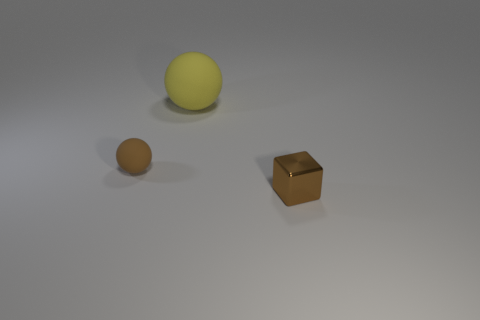There is a brown object in front of the brown thing behind the brown block; how big is it?
Provide a short and direct response. Small. What number of other objects are there of the same size as the yellow object?
Give a very brief answer. 0. Is there a large cyan rubber object of the same shape as the metal thing?
Offer a very short reply. No. What number of other objects are the same shape as the tiny brown metallic thing?
Ensure brevity in your answer.  0. There is a big rubber thing; does it have the same shape as the tiny brown thing to the left of the big matte thing?
Offer a terse response. Yes. Is there any other thing that is made of the same material as the yellow sphere?
Keep it short and to the point. Yes. What material is the large object that is the same shape as the small rubber object?
Provide a succinct answer. Rubber. How many tiny objects are yellow rubber spheres or blue metal cylinders?
Make the answer very short. 0. Are there fewer big yellow matte things on the left side of the brown metallic thing than yellow rubber spheres right of the large rubber thing?
Provide a short and direct response. No. How many things are matte things or yellow cylinders?
Your response must be concise. 2. 